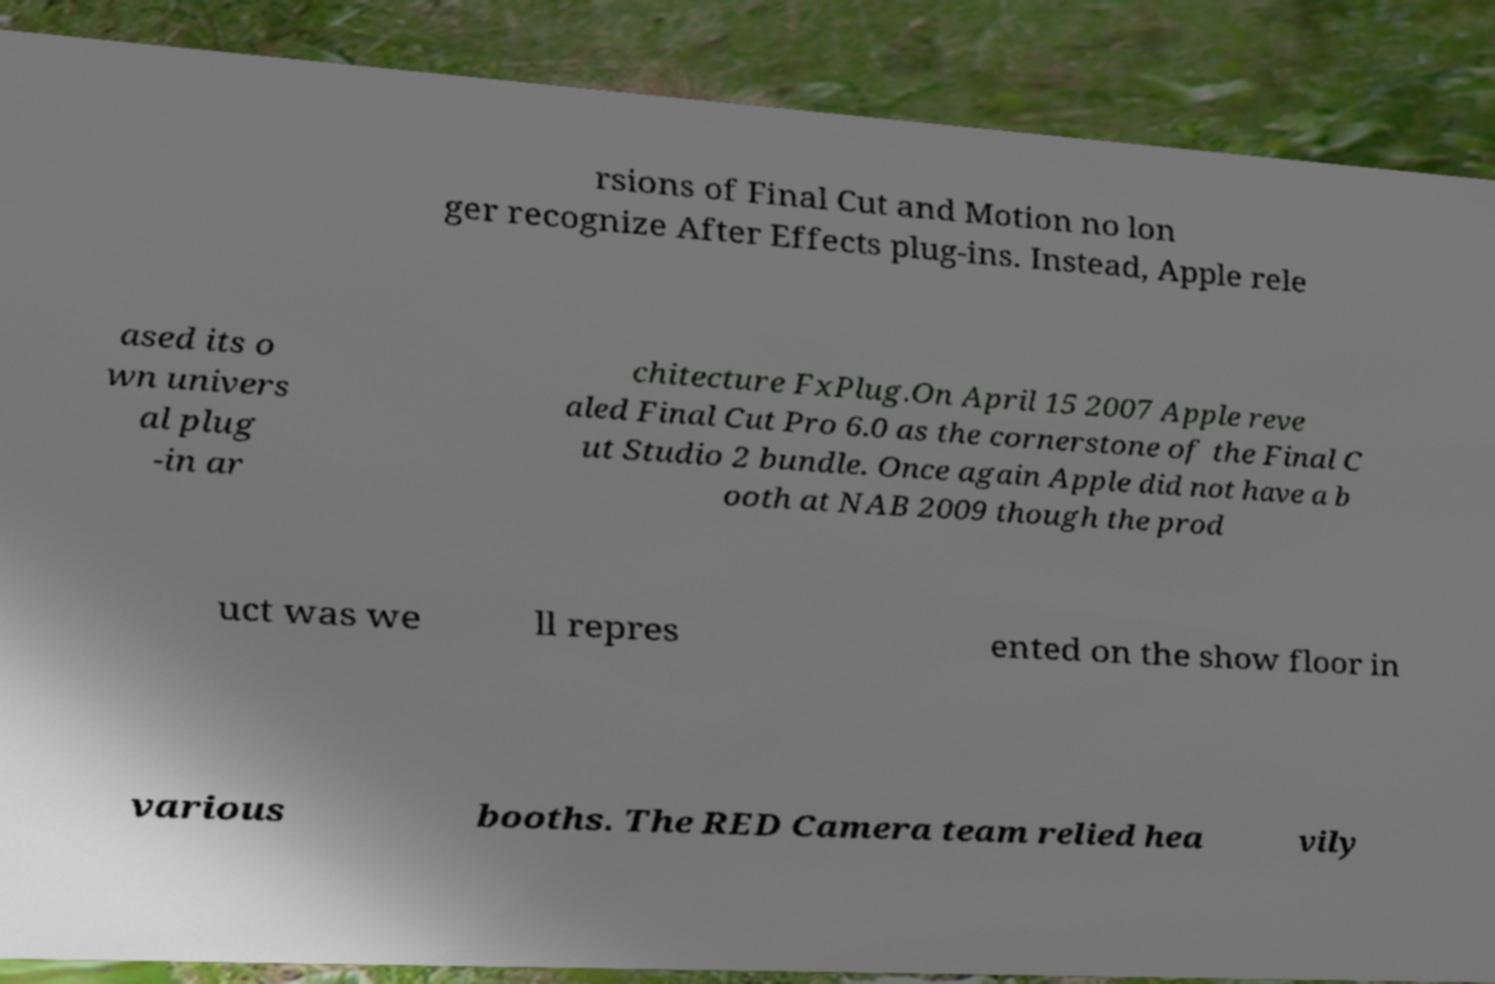Could you assist in decoding the text presented in this image and type it out clearly? rsions of Final Cut and Motion no lon ger recognize After Effects plug-ins. Instead, Apple rele ased its o wn univers al plug -in ar chitecture FxPlug.On April 15 2007 Apple reve aled Final Cut Pro 6.0 as the cornerstone of the Final C ut Studio 2 bundle. Once again Apple did not have a b ooth at NAB 2009 though the prod uct was we ll repres ented on the show floor in various booths. The RED Camera team relied hea vily 